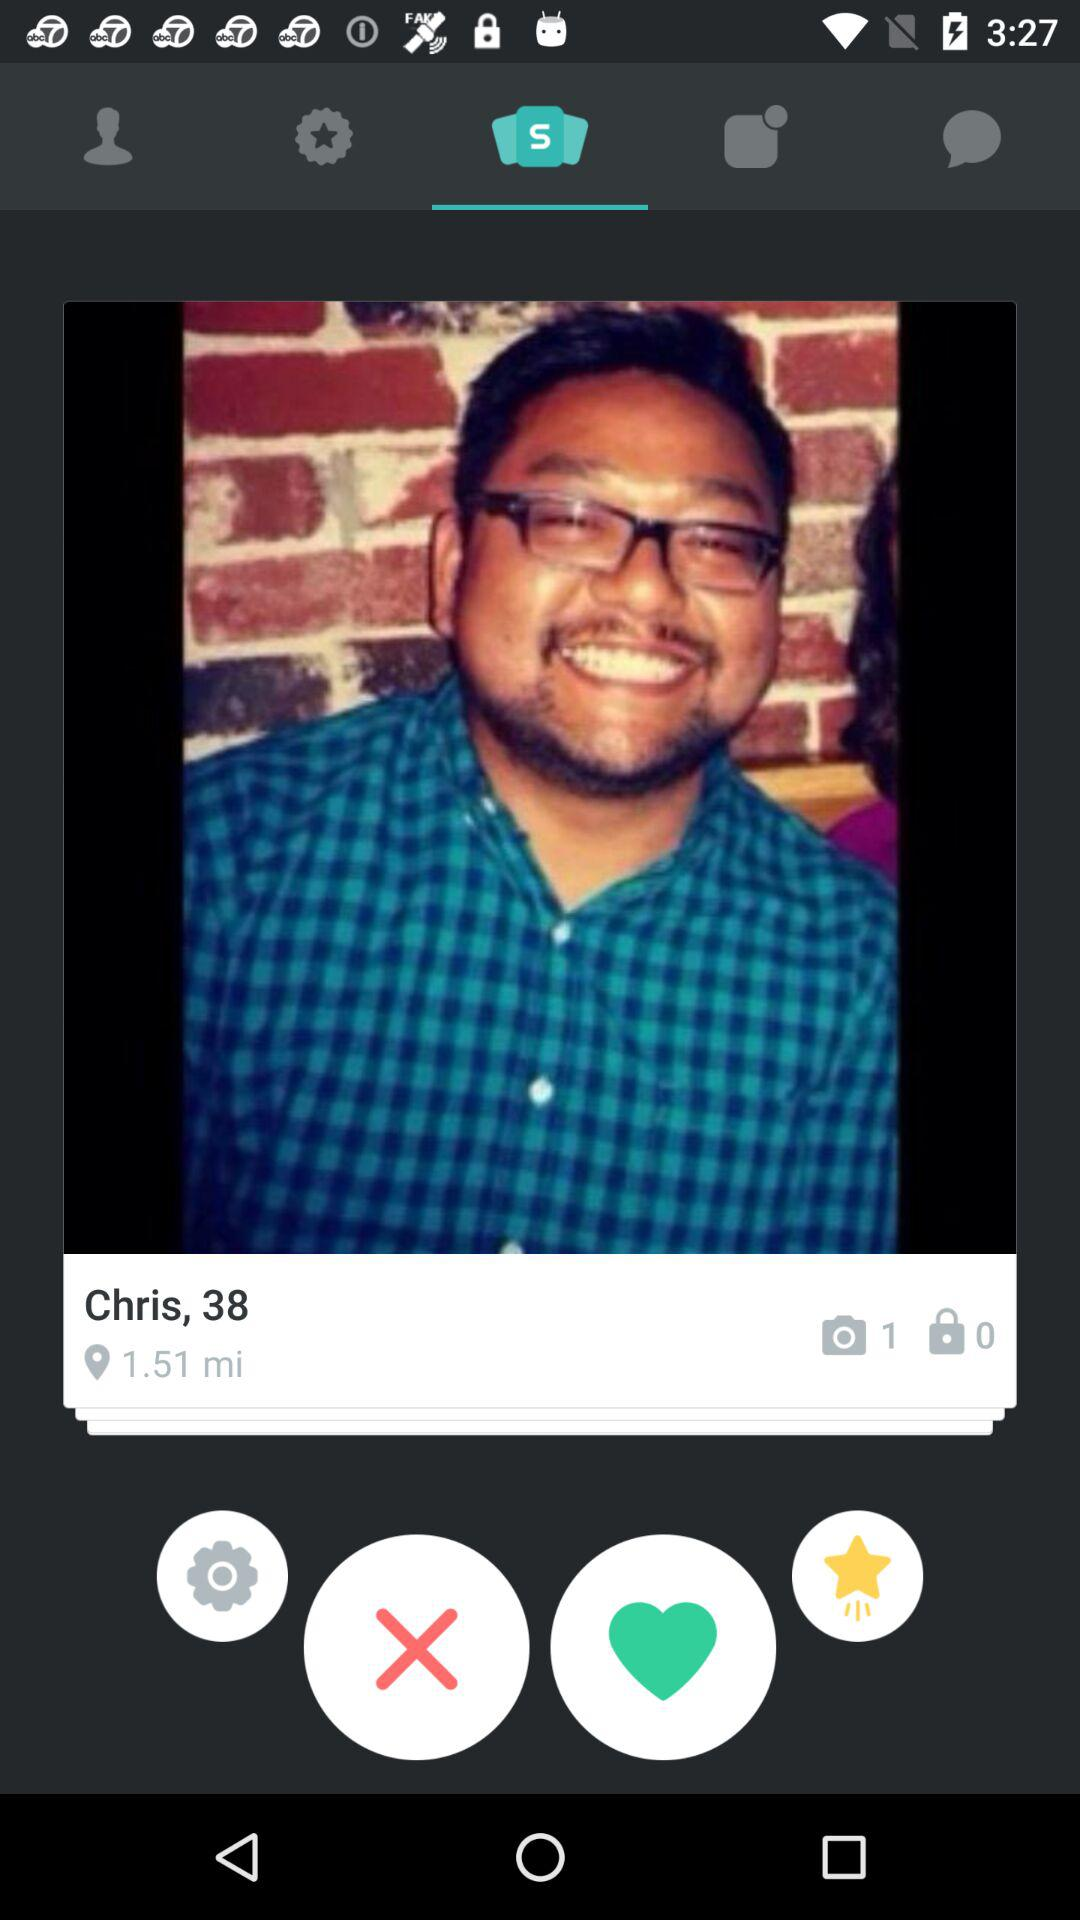What's the location?
When the provided information is insufficient, respond with <no answer>. <no answer> 